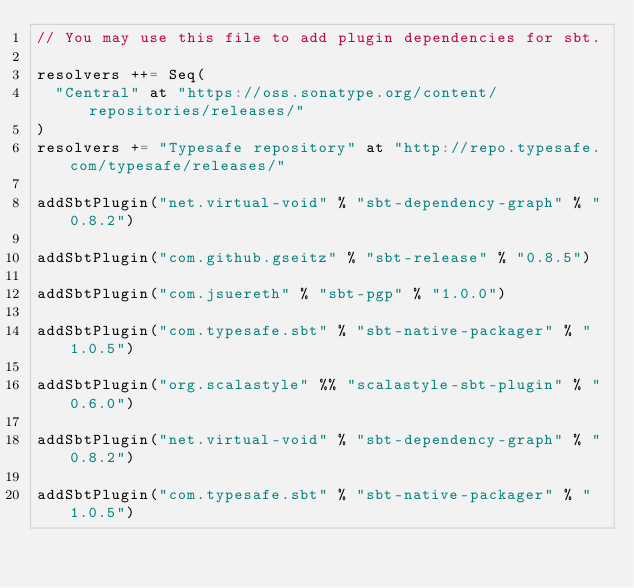<code> <loc_0><loc_0><loc_500><loc_500><_Scala_>// You may use this file to add plugin dependencies for sbt.

resolvers ++= Seq(
  "Central" at "https://oss.sonatype.org/content/repositories/releases/"
)
resolvers += "Typesafe repository" at "http://repo.typesafe.com/typesafe/releases/"

addSbtPlugin("net.virtual-void" % "sbt-dependency-graph" % "0.8.2")

addSbtPlugin("com.github.gseitz" % "sbt-release" % "0.8.5")

addSbtPlugin("com.jsuereth" % "sbt-pgp" % "1.0.0")

addSbtPlugin("com.typesafe.sbt" % "sbt-native-packager" % "1.0.5")

addSbtPlugin("org.scalastyle" %% "scalastyle-sbt-plugin" % "0.6.0")

addSbtPlugin("net.virtual-void" % "sbt-dependency-graph" % "0.8.2")

addSbtPlugin("com.typesafe.sbt" % "sbt-native-packager" % "1.0.5")</code> 